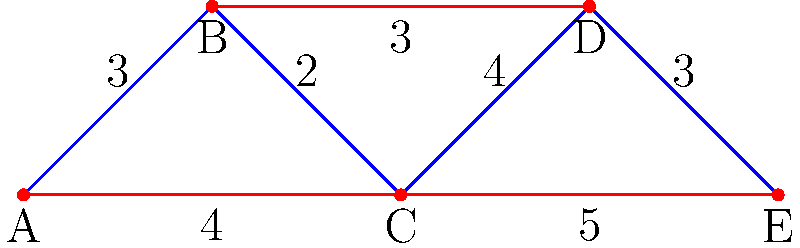In the subway system represented by the graph above, each station is labeled with a letter, and the numbers on the edges represent the travel time in minutes between stations. As a future educator, you want to find the quickest route to travel from station A to station E to observe different school environments. What is the shortest time (in minutes) to travel from station A to station E? To find the shortest path from station A to station E, we'll use Dijkstra's algorithm:

1. Initialize:
   - Distance to A: 0
   - Distance to all other stations: infinity

2. Visit A:
   - Update B: 0 + 3 = 3
   - Update C: 0 + 4 = 4

3. Visit B (shortest unvisited):
   - Update C: min(4, 3 + 2) = 4 (no change)
   - Update D: 3 + 3 = 6

4. Visit C:
   - Update D: min(6, 4 + 4) = 6 (no change)
   - Update E: 4 + 5 = 9

5. Visit D:
   - Update E: min(9, 6 + 3) = 9 (no change)

6. Visit E (destination reached)

The shortest path is A -> C -> E, with a total time of 9 minutes.
Answer: 9 minutes 